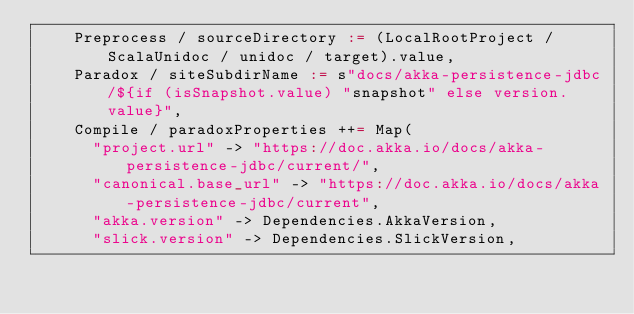<code> <loc_0><loc_0><loc_500><loc_500><_Scala_>    Preprocess / sourceDirectory := (LocalRootProject / ScalaUnidoc / unidoc / target).value,
    Paradox / siteSubdirName := s"docs/akka-persistence-jdbc/${if (isSnapshot.value) "snapshot" else version.value}",
    Compile / paradoxProperties ++= Map(
      "project.url" -> "https://doc.akka.io/docs/akka-persistence-jdbc/current/",
      "canonical.base_url" -> "https://doc.akka.io/docs/akka-persistence-jdbc/current",
      "akka.version" -> Dependencies.AkkaVersion,
      "slick.version" -> Dependencies.SlickVersion,</code> 